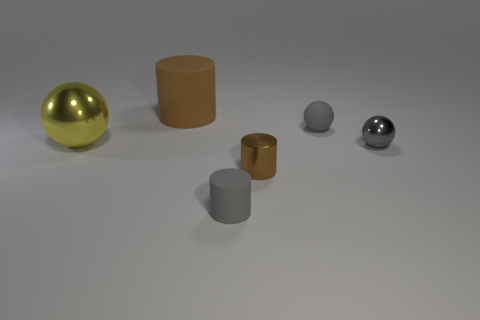What is the shape of the big thing that is the same color as the tiny metallic cylinder?
Make the answer very short. Cylinder. What number of yellow things are either small matte things or spheres?
Your answer should be compact. 1. The brown rubber object is what size?
Your response must be concise. Large. Are there more tiny gray spheres that are behind the small gray rubber cylinder than gray cylinders?
Your answer should be very brief. Yes. There is a small gray metal sphere; how many metal spheres are left of it?
Your answer should be compact. 1. Is there a cylinder that has the same size as the brown metallic thing?
Provide a succinct answer. Yes. There is another tiny object that is the same shape as the tiny brown metallic thing; what color is it?
Keep it short and to the point. Gray. There is a gray rubber thing that is right of the tiny gray rubber cylinder; is its size the same as the rubber cylinder that is in front of the large cylinder?
Offer a very short reply. Yes. Is there another object that has the same shape as the big metallic thing?
Offer a very short reply. Yes. Are there the same number of large yellow shiny objects right of the tiny rubber cylinder and tiny red spheres?
Keep it short and to the point. Yes. 